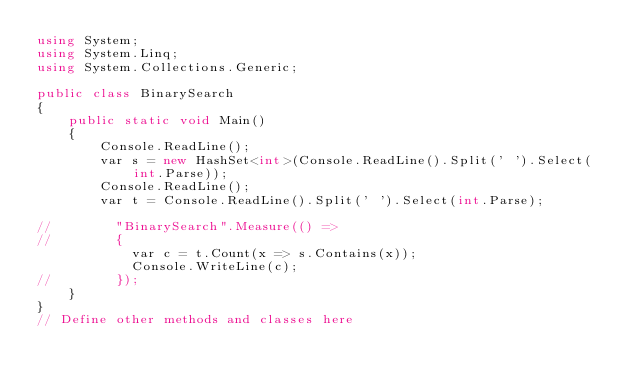<code> <loc_0><loc_0><loc_500><loc_500><_C#_>using System;
using System.Linq;
using System.Collections.Generic;

public class BinarySearch
{
    public static void Main()
    {
        Console.ReadLine();
        var s = new HashSet<int>(Console.ReadLine().Split(' ').Select(int.Parse));
        Console.ReadLine();
        var t = Console.ReadLine().Split(' ').Select(int.Parse);
    
//        "BinarySearch".Measure(() =>
//        {
            var c = t.Count(x => s.Contains(x));
            Console.WriteLine(c);
//        });
    }
}
// Define other methods and classes here</code> 